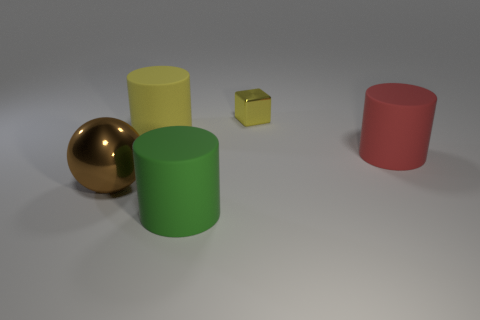Is the shape of the big yellow thing the same as the large matte thing that is in front of the big red matte cylinder?
Offer a very short reply. Yes. There is a large object that is the same material as the yellow cube; what is its shape?
Make the answer very short. Sphere. Is the number of cylinders to the right of the green rubber cylinder greater than the number of green rubber objects that are to the right of the big red thing?
Keep it short and to the point. Yes. What number of things are rubber things or metal objects?
Give a very brief answer. 5. What number of other objects are there of the same color as the tiny shiny block?
Your response must be concise. 1. What is the shape of the green object that is the same size as the yellow matte cylinder?
Keep it short and to the point. Cylinder. There is a large rubber object left of the big green cylinder; what color is it?
Give a very brief answer. Yellow. What number of objects are either rubber cylinders right of the green matte object or things right of the large sphere?
Ensure brevity in your answer.  4. Is the green cylinder the same size as the red matte thing?
Provide a short and direct response. Yes. What number of cylinders are either green matte things or shiny things?
Offer a terse response. 1. 